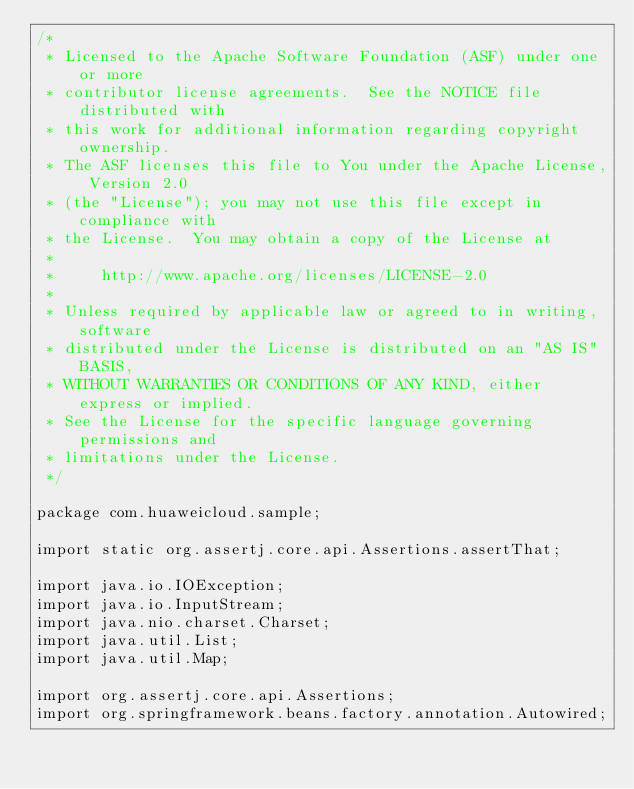Convert code to text. <code><loc_0><loc_0><loc_500><loc_500><_Java_>/*
 * Licensed to the Apache Software Foundation (ASF) under one or more
 * contributor license agreements.  See the NOTICE file distributed with
 * this work for additional information regarding copyright ownership.
 * The ASF licenses this file to You under the Apache License, Version 2.0
 * (the "License"); you may not use this file except in compliance with
 * the License.  You may obtain a copy of the License at
 *
 *     http://www.apache.org/licenses/LICENSE-2.0
 *
 * Unless required by applicable law or agreed to in writing, software
 * distributed under the License is distributed on an "AS IS" BASIS,
 * WITHOUT WARRANTIES OR CONDITIONS OF ANY KIND, either express or implied.
 * See the License for the specific language governing permissions and
 * limitations under the License.
 */

package com.huaweicloud.sample;

import static org.assertj.core.api.Assertions.assertThat;

import java.io.IOException;
import java.io.InputStream;
import java.nio.charset.Charset;
import java.util.List;
import java.util.Map;

import org.assertj.core.api.Assertions;
import org.springframework.beans.factory.annotation.Autowired;</code> 